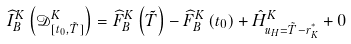<formula> <loc_0><loc_0><loc_500><loc_500>\widehat { I } ^ { K } _ { B } \left ( \mathcal { D } ^ { K } _ { [ t _ { 0 } , \tilde { T } ] } \right ) = \widehat { F } ^ { K } _ { B } \left ( \tilde { T } \right ) - \widehat { F } ^ { K } _ { B } \left ( t _ { 0 } \right ) + \hat { H } ^ { K } _ { u _ { H } = \tilde { T } - r _ { K } ^ { ^ { * } } } + 0</formula> 